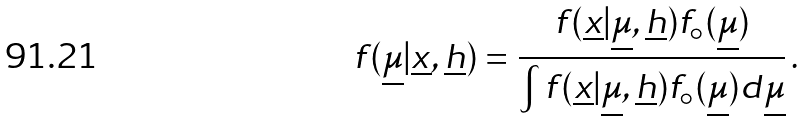<formula> <loc_0><loc_0><loc_500><loc_500>f ( \underline { \mu } | \underline { x } , \underline { h } ) = \frac { f ( \underline { x } | \underline { \mu } , \underline { h } ) f _ { \circ } ( \underline { \mu } ) } { \int f ( \underline { x } | \underline { \mu } , \underline { h } ) f _ { \circ } ( \underline { \mu } ) d \underline { \mu } } \, .</formula> 